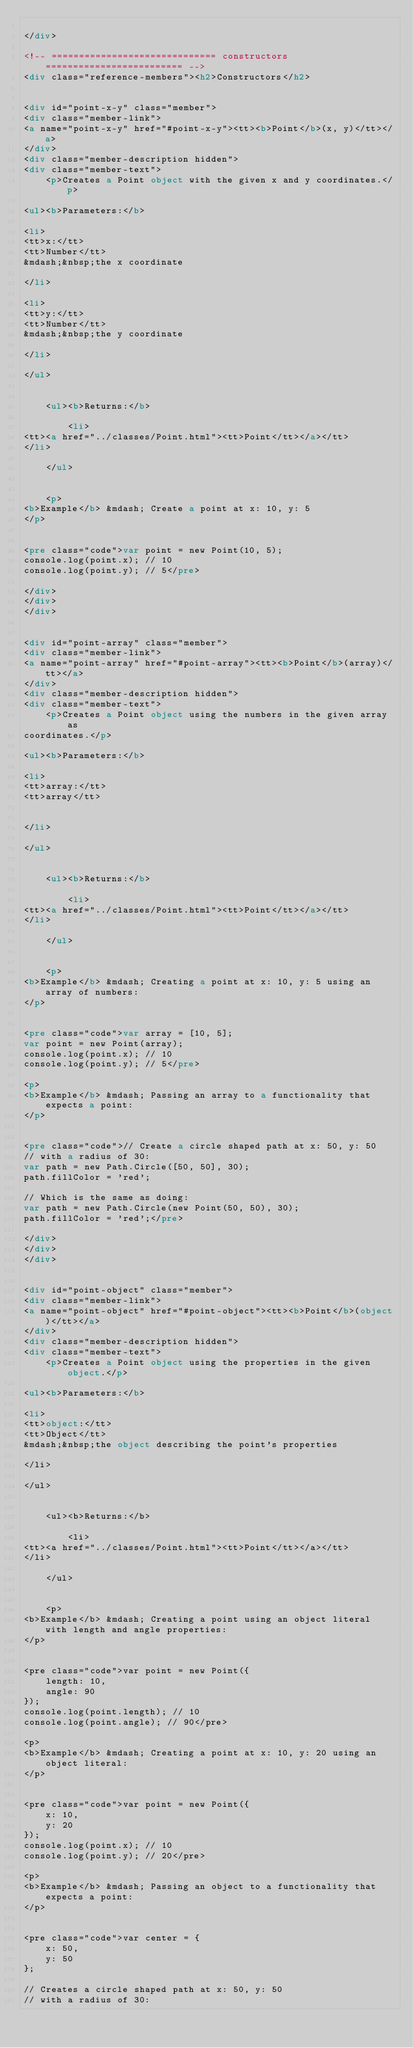Convert code to text. <code><loc_0><loc_0><loc_500><loc_500><_HTML_>
</div>

<!-- ============================== constructors ========================= -->
<div class="reference-members"><h2>Constructors</h2>
	
		
<div id="point-x-y" class="member">
<div class="member-link">
<a name="point-x-y" href="#point-x-y"><tt><b>Point</b>(x, y)</tt></a>
</div>
<div class="member-description hidden">
<div class="member-text">
    <p>Creates a Point object with the given x and y coordinates.</p>
    
<ul><b>Parameters:</b>

<li>
<tt>x:</tt> 
<tt>Number</tt>
&mdash;&nbsp;the x coordinate

</li>

<li>
<tt>y:</tt> 
<tt>Number</tt>
&mdash;&nbsp;the y coordinate

</li>

</ul>

    
	<ul><b>Returns:</b>
	
		<li>
<tt><a href="../classes/Point.html"><tt>Point</tt></a></tt>
</li>
	
	</ul>

    
    <p>
<b>Example</b> &mdash; Create a point at x: 10, y: 5
</p>


<pre class="code">var point = new Point(10, 5);
console.log(point.x); // 10
console.log(point.y); // 5</pre>

</div>
</div>
</div>
	
		
<div id="point-array" class="member">
<div class="member-link">
<a name="point-array" href="#point-array"><tt><b>Point</b>(array)</tt></a>
</div>
<div class="member-description hidden">
<div class="member-text">
    <p>Creates a Point object using the numbers in the given array as
coordinates.</p>
    
<ul><b>Parameters:</b>

<li>
<tt>array:</tt> 
<tt>array</tt>


</li>

</ul>

    
	<ul><b>Returns:</b>
	
		<li>
<tt><a href="../classes/Point.html"><tt>Point</tt></a></tt>
</li>
	
	</ul>

    
    <p>
<b>Example</b> &mdash; Creating a point at x: 10, y: 5 using an array of numbers:
</p>


<pre class="code">var array = [10, 5];
var point = new Point(array);
console.log(point.x); // 10
console.log(point.y); // 5</pre>

<p>
<b>Example</b> &mdash; Passing an array to a functionality that expects a point:
</p>


<pre class="code">// Create a circle shaped path at x: 50, y: 50
// with a radius of 30:
var path = new Path.Circle([50, 50], 30);
path.fillColor = 'red';

// Which is the same as doing:
var path = new Path.Circle(new Point(50, 50), 30);
path.fillColor = 'red';</pre>

</div>
</div>
</div>
	
		
<div id="point-object" class="member">
<div class="member-link">
<a name="point-object" href="#point-object"><tt><b>Point</b>(object)</tt></a>
</div>
<div class="member-description hidden">
<div class="member-text">
    <p>Creates a Point object using the properties in the given object.</p>
    
<ul><b>Parameters:</b>

<li>
<tt>object:</tt> 
<tt>Object</tt>
&mdash;&nbsp;the object describing the point's properties

</li>

</ul>

    
	<ul><b>Returns:</b>
	
		<li>
<tt><a href="../classes/Point.html"><tt>Point</tt></a></tt>
</li>
	
	</ul>

    
    <p>
<b>Example</b> &mdash; Creating a point using an object literal with length and angle properties:
</p>


<pre class="code">var point = new Point({
    length: 10,
    angle: 90
});
console.log(point.length); // 10
console.log(point.angle); // 90</pre>

<p>
<b>Example</b> &mdash; Creating a point at x: 10, y: 20 using an object literal:
</p>


<pre class="code">var point = new Point({
    x: 10,
    y: 20
});
console.log(point.x); // 10
console.log(point.y); // 20</pre>

<p>
<b>Example</b> &mdash; Passing an object to a functionality that expects a point:
</p>


<pre class="code">var center = {
    x: 50,
    y: 50
};

// Creates a circle shaped path at x: 50, y: 50
// with a radius of 30:</code> 